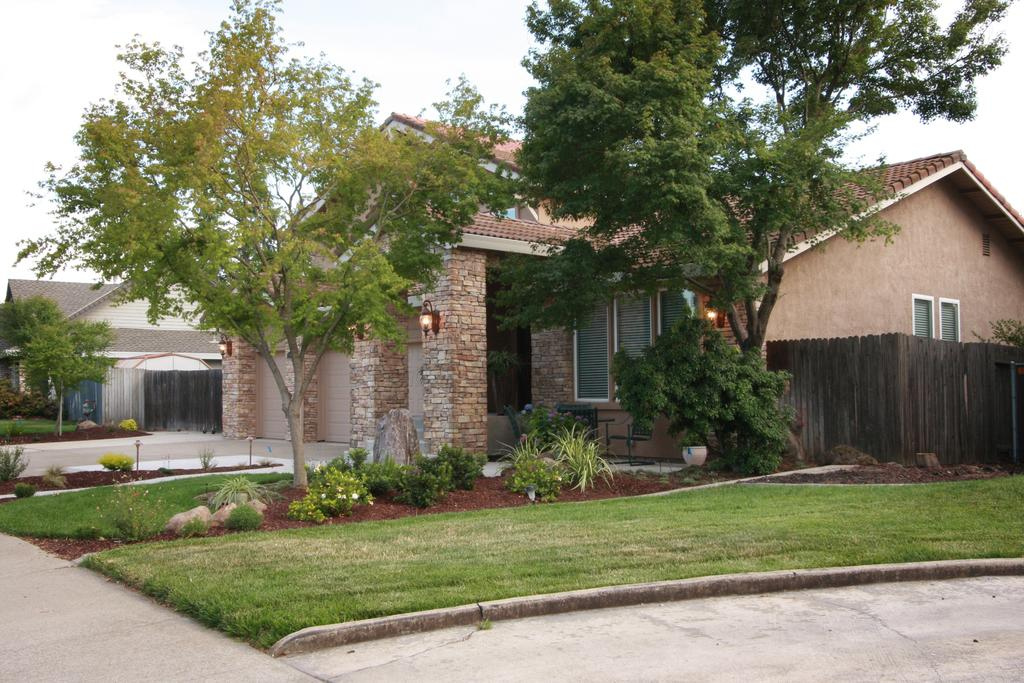What type of structures can be seen in the image? There are buildings in the image. What type of vegetation is present in the image? There are trees and plants in the image. How many friends are visible in the image? There is no reference to friends or people in the image, so it is not possible to answer that question. 